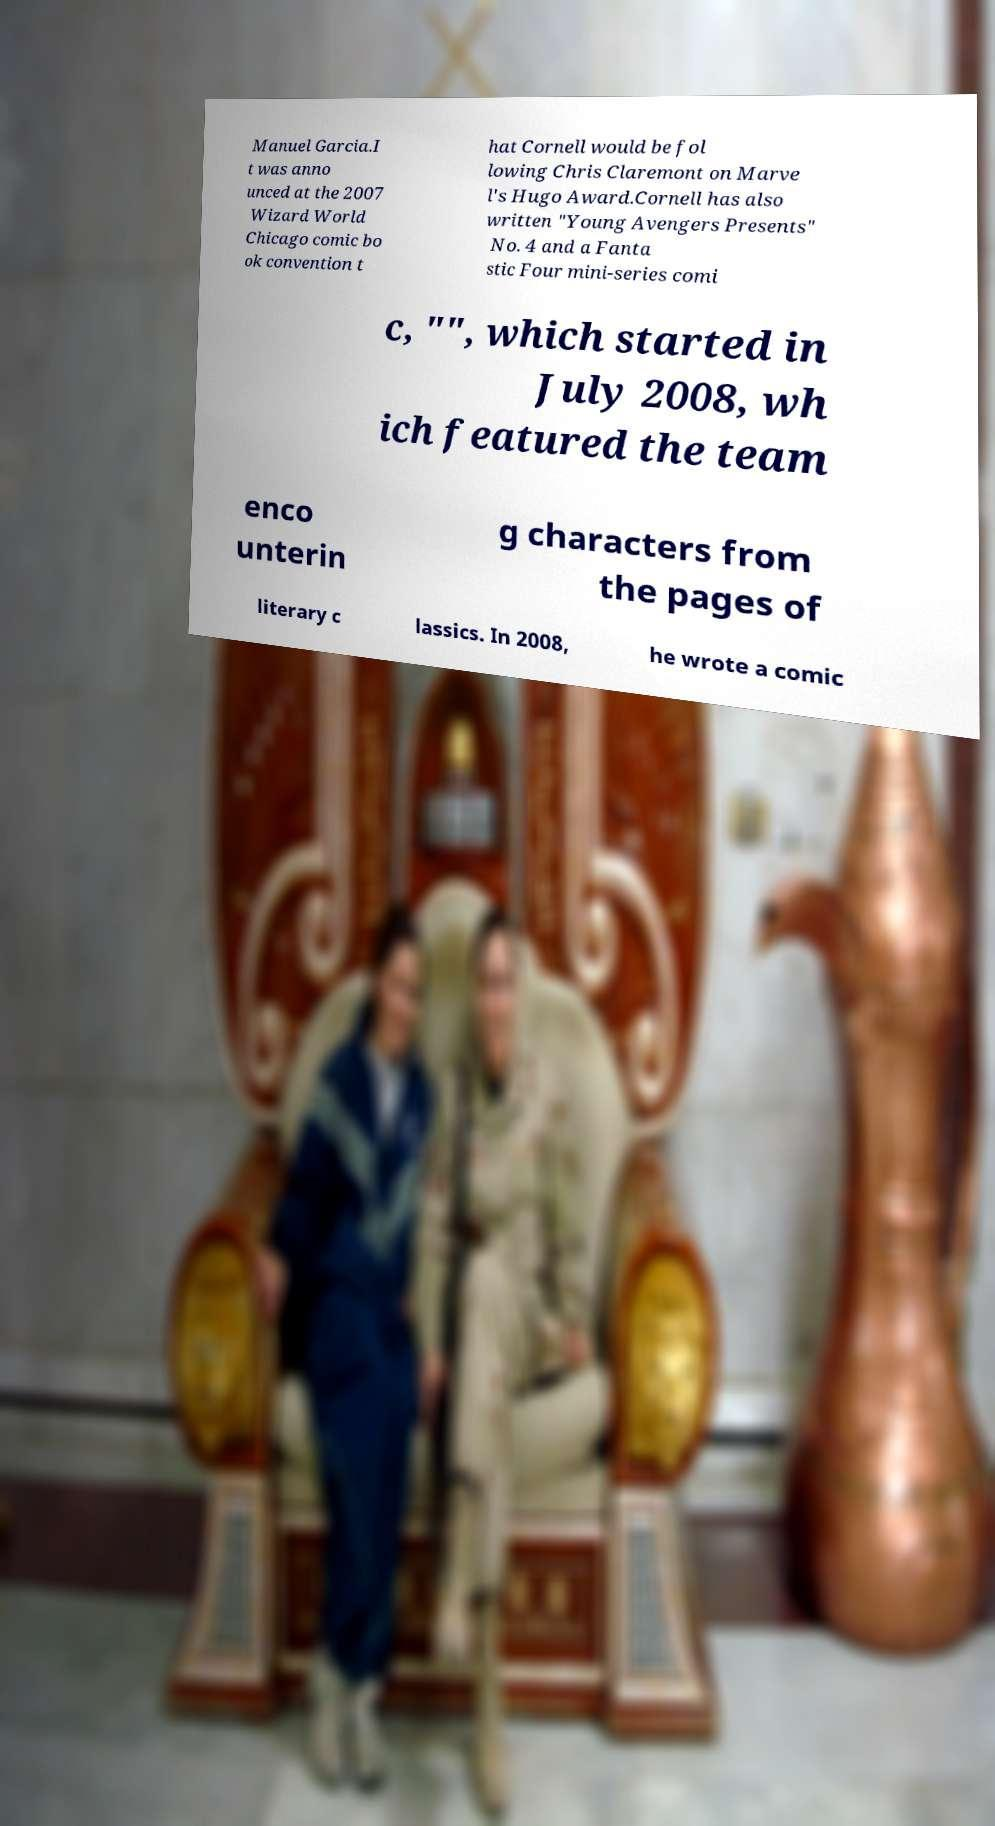What messages or text are displayed in this image? I need them in a readable, typed format. Manuel Garcia.I t was anno unced at the 2007 Wizard World Chicago comic bo ok convention t hat Cornell would be fol lowing Chris Claremont on Marve l's Hugo Award.Cornell has also written "Young Avengers Presents" No. 4 and a Fanta stic Four mini-series comi c, "", which started in July 2008, wh ich featured the team enco unterin g characters from the pages of literary c lassics. In 2008, he wrote a comic 